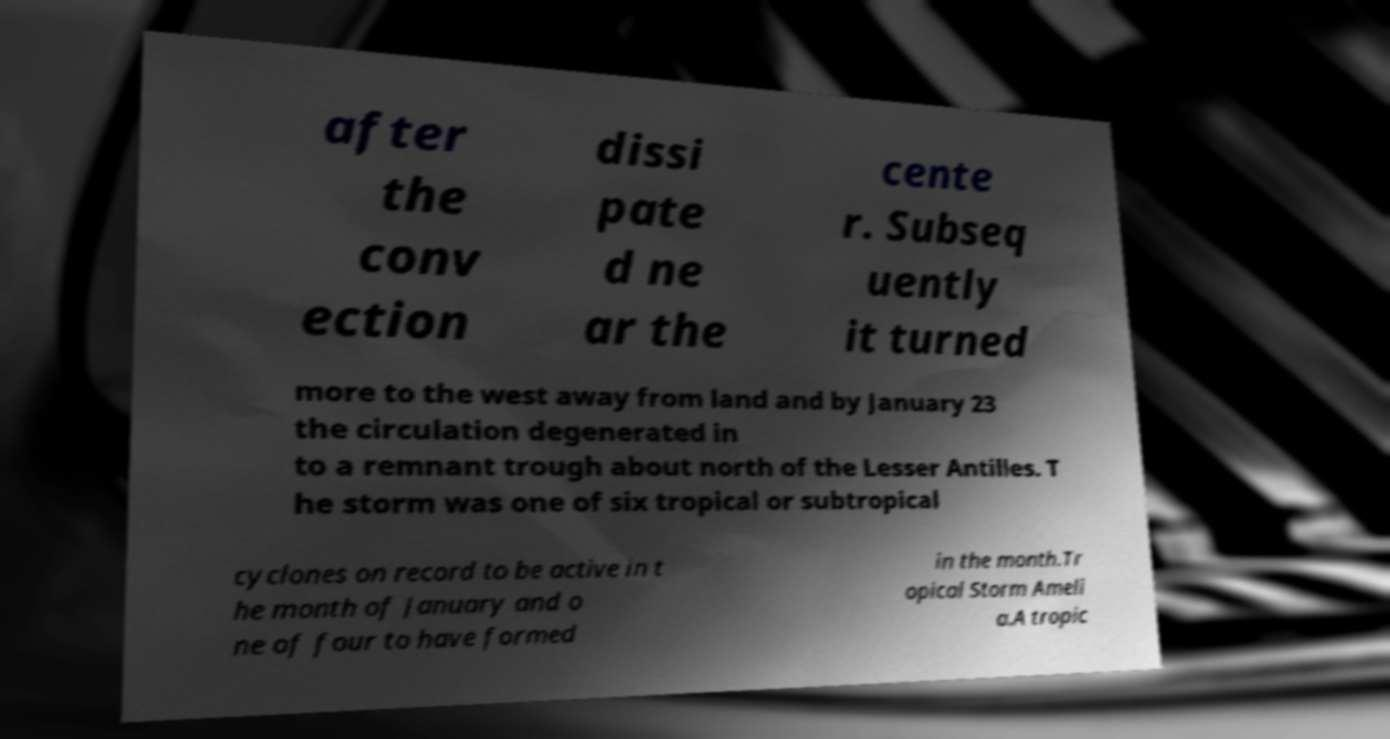Could you extract and type out the text from this image? after the conv ection dissi pate d ne ar the cente r. Subseq uently it turned more to the west away from land and by January 23 the circulation degenerated in to a remnant trough about north of the Lesser Antilles. T he storm was one of six tropical or subtropical cyclones on record to be active in t he month of January and o ne of four to have formed in the month.Tr opical Storm Ameli a.A tropic 